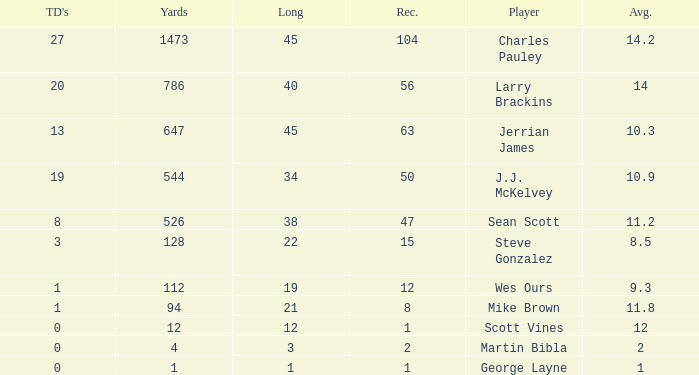What is the average for wes ours with over 1 reception and under 1 TD? None. 